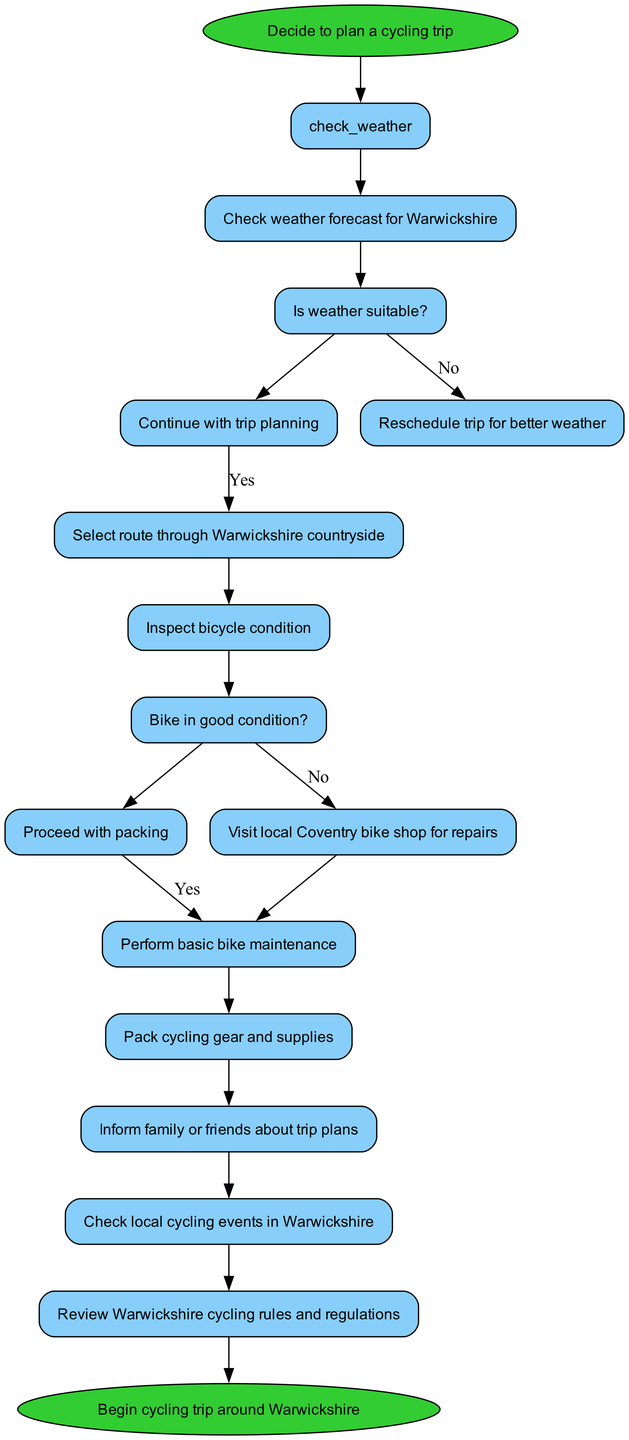What is the starting point of the diagram? The starting point of the diagram is marked as "Decide to plan a cycling trip," which indicates where the process begins.
Answer: Decide to plan a cycling trip How many activities are there in the diagram? The diagram contains a total of eight activities listed, which can be counted directly from the activities section.
Answer: 8 What is the decision condition related to the bicycle? The decision condition regarding the bicycle asks "Bike in good condition?" which directly corresponds to the decision point dealing with bicycle readiness.
Answer: Bike in good condition? What happens if the weather is not suitable? If the weather is not suitable, the flow leads to "Reschedule trip for better weather," indicating a change in the trip schedule based on the weather condition.
Answer: Reschedule trip for better weather Which activity follows the decision about the bicycle condition if it is good? The activity that follows if the bicycle is in good condition is "Pack cycling gear and supplies," as per the flow of the diagram from the decision node.
Answer: Pack cycling gear and supplies How many decision nodes are present in the diagram? There are two decision nodes present in the diagram, one related to weather and the other related to bicycle condition, which can be counted in the decisions section.
Answer: 2 What do you need to do if the bicycle is not in good condition? If the bicycle is not in good condition, the flow indicates that one should "Visit local Coventry bike shop for repairs," which is the required action per the decision path.
Answer: Visit local Coventry bike shop for repairs Which activity occurs immediately after checking the weather? After checking the weather, the next activity that occurs is "Select route through Warwickshire countryside," as per the sequential flow from the initial activity.
Answer: Select route through Warwickshire countryside What is the final action in the cycling trip planning process? The final action in the cycling trip planning process is marked as "Begin cycling trip around Warwickshire," which follows the last activity in sequence.
Answer: Begin cycling trip around Warwickshire 